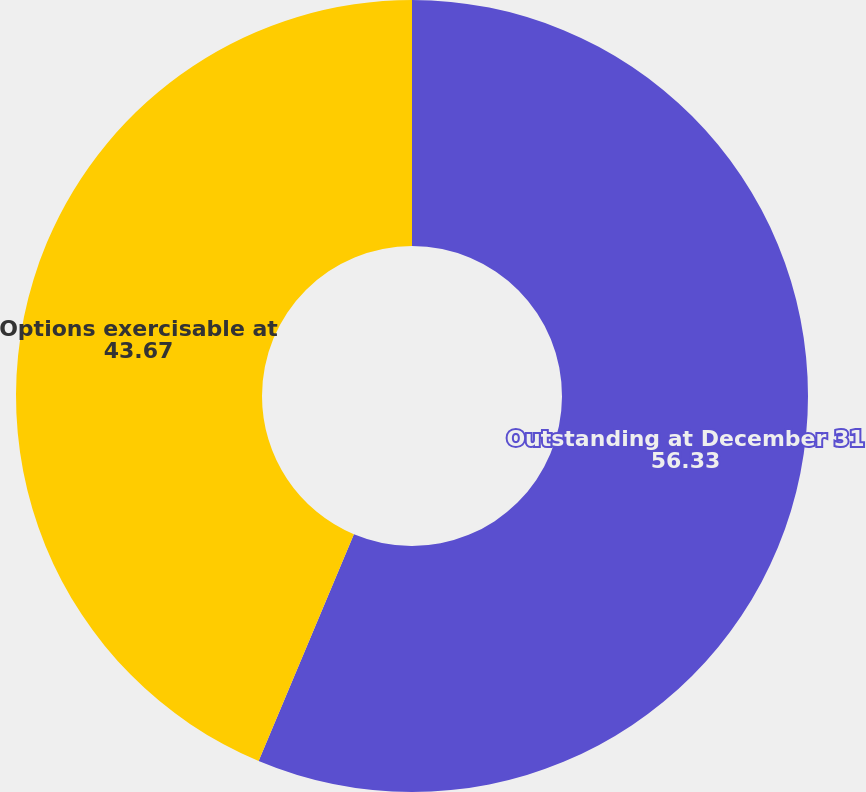Convert chart to OTSL. <chart><loc_0><loc_0><loc_500><loc_500><pie_chart><fcel>Outstanding at December 31<fcel>Options exercisable at<nl><fcel>56.33%<fcel>43.67%<nl></chart> 